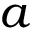Convert formula to latex. <formula><loc_0><loc_0><loc_500><loc_500>a</formula> 